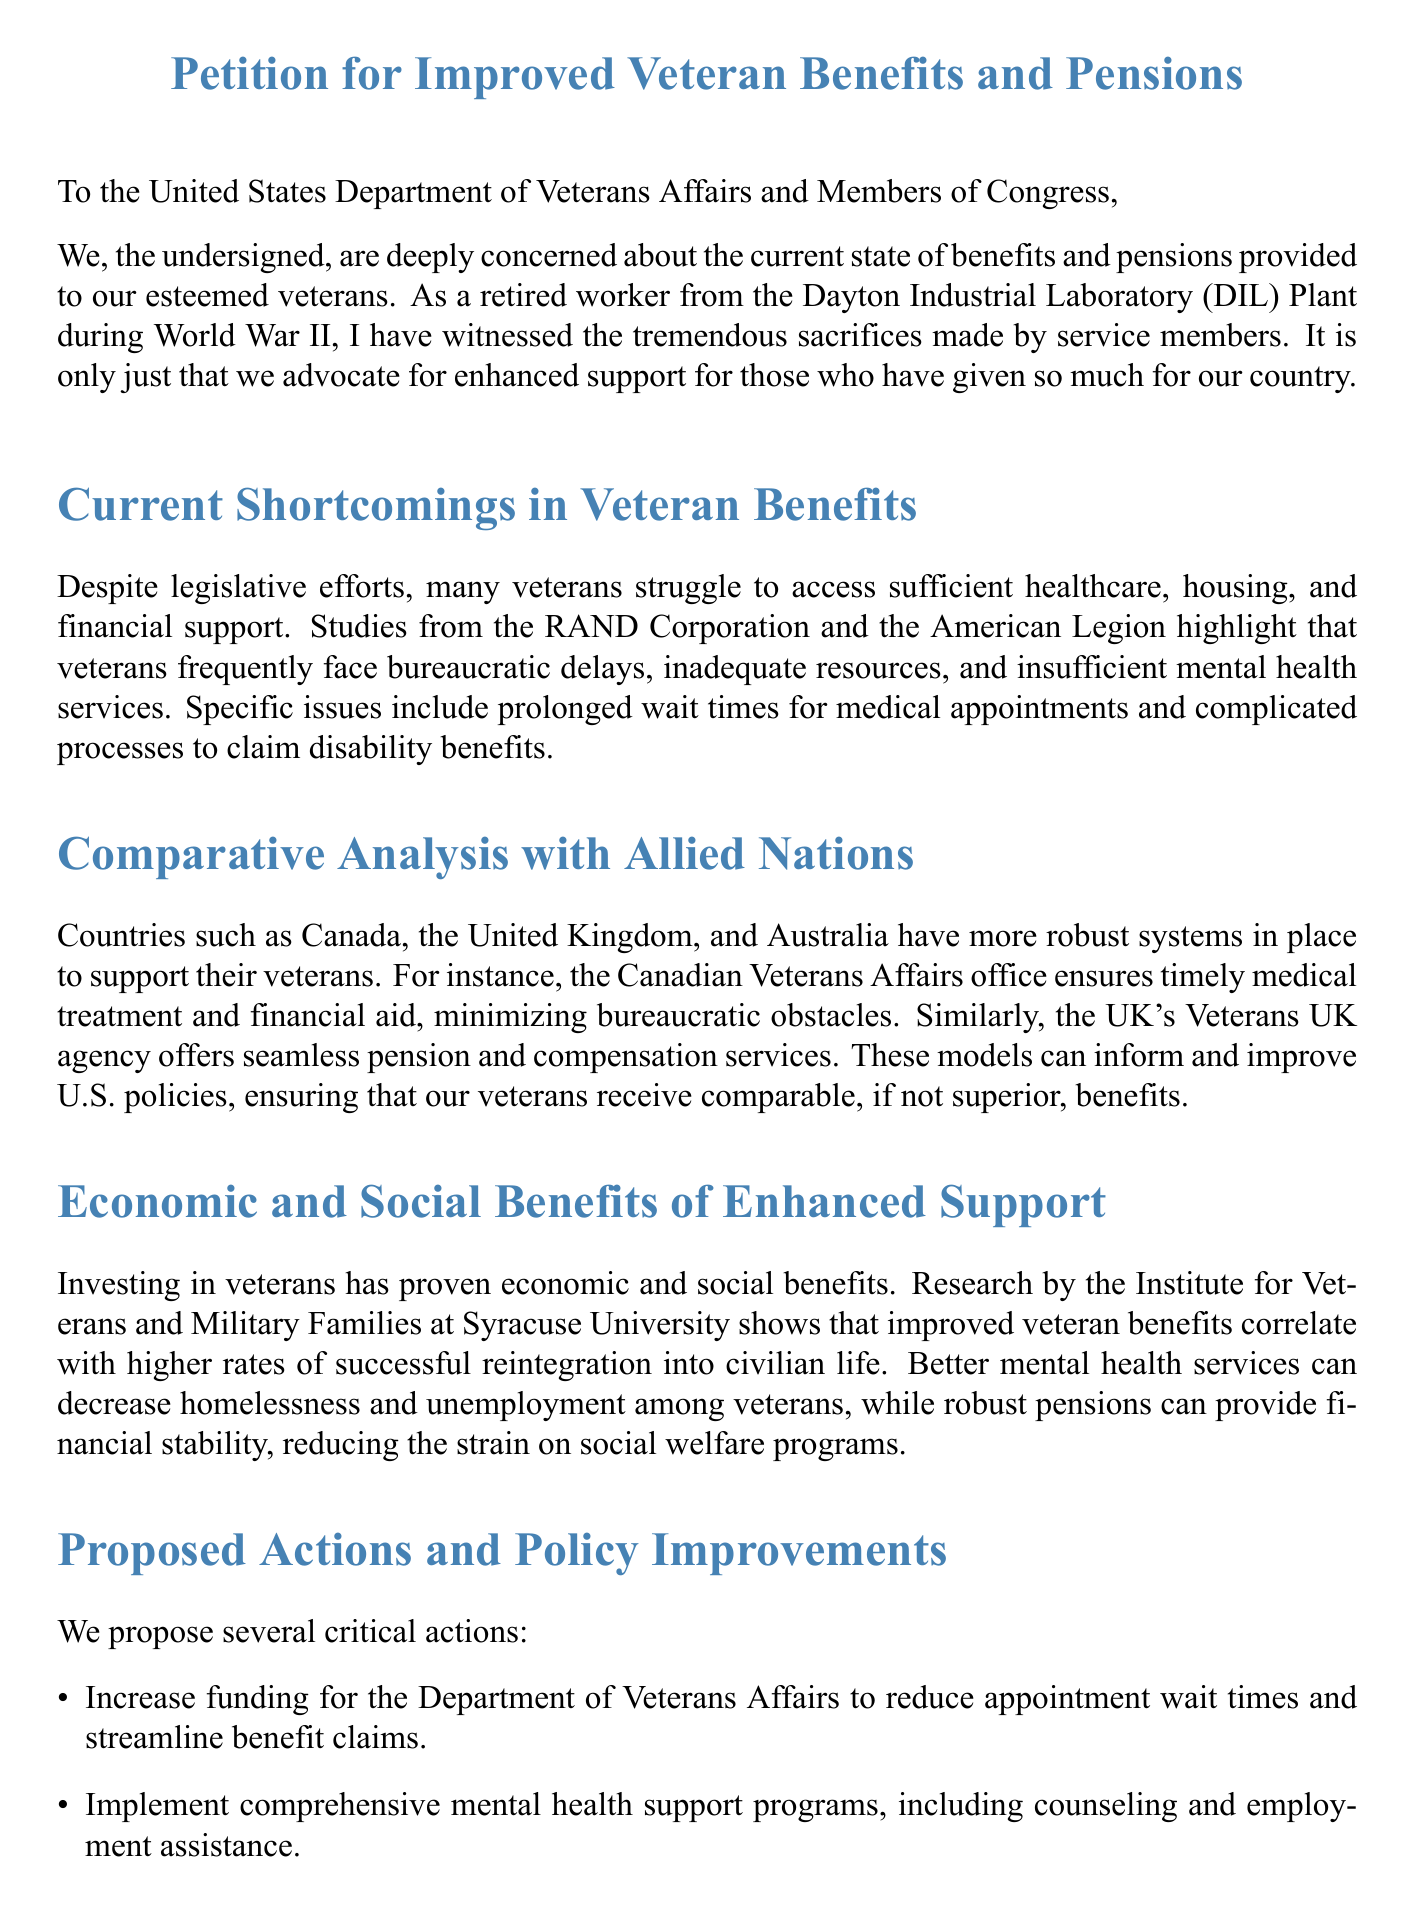What is the document titled? The title of the document is mentioned at the top as "Petition for Improved Veteran Benefits and Pensions."
Answer: Petition for Improved Veteran Benefits and Pensions Who are the primary recipients of this petition? The petition is addressed to the United States Department of Veterans Affairs and Members of Congress.
Answer: United States Department of Veterans Affairs and Members of Congress What significant issue is mentioned regarding healthcare for veterans? The document states that veterans face bureaucratic delays and insufficient mental health services, specifically mentioning "prolonged wait times for medical appointments."
Answer: Prolonged wait times for medical appointments Which countries are compared to the U.S. regarding veteran support? The document compares the United States' veteran support to that of Canada, the United Kingdom, and Australia.
Answer: Canada, the United Kingdom, and Australia What is one proposed action to improve veteran benefits? One of the critical actions proposed in the document is to "increase funding for the Department of Veterans Affairs."
Answer: Increase funding for the Department of Veterans Affairs What is the economic benefit mentioned for investing in veterans? The document refers to "higher rates of successful reintegration into civilian life" as an economic benefit of improved veteran benefits.
Answer: Higher rates of successful reintegration into civilian life What is the concluding call to action? The conclusion urges to "prioritize the well-being of our veterans by enacting these proposals."
Answer: Prioritize the well-being of our veterans by enacting these proposals How does the document classify itself? The document is labeled as a petition, which is indicated in the title and throughout its structure.
Answer: Petition 